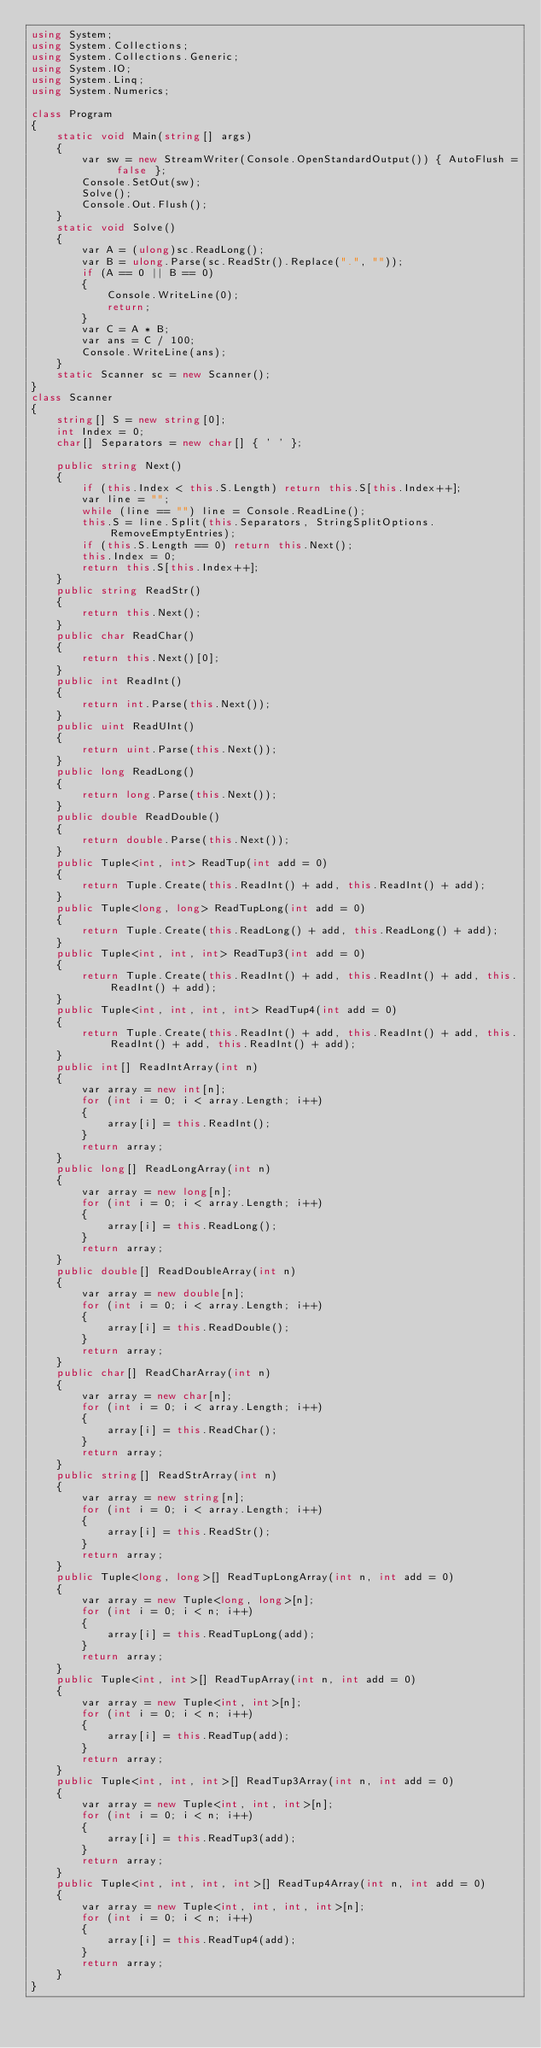<code> <loc_0><loc_0><loc_500><loc_500><_C#_>using System;
using System.Collections;
using System.Collections.Generic;
using System.IO;
using System.Linq;
using System.Numerics;

class Program
{
    static void Main(string[] args)
    {
        var sw = new StreamWriter(Console.OpenStandardOutput()) { AutoFlush = false };
        Console.SetOut(sw);
        Solve();
        Console.Out.Flush();
    }
    static void Solve()
    {
        var A = (ulong)sc.ReadLong();
        var B = ulong.Parse(sc.ReadStr().Replace(".", ""));
        if (A == 0 || B == 0)
        {
            Console.WriteLine(0);
            return;
        }
        var C = A * B;
        var ans = C / 100;
        Console.WriteLine(ans);
    }
    static Scanner sc = new Scanner();
}
class Scanner
{
    string[] S = new string[0];
    int Index = 0;
    char[] Separators = new char[] { ' ' };

    public string Next()
    {
        if (this.Index < this.S.Length) return this.S[this.Index++];
        var line = "";
        while (line == "") line = Console.ReadLine();
        this.S = line.Split(this.Separators, StringSplitOptions.RemoveEmptyEntries);
        if (this.S.Length == 0) return this.Next();
        this.Index = 0;
        return this.S[this.Index++];
    }
    public string ReadStr()
    {
        return this.Next();
    }
    public char ReadChar()
    {
        return this.Next()[0];
    }
    public int ReadInt()
    {
        return int.Parse(this.Next());
    }
    public uint ReadUInt()
    {
        return uint.Parse(this.Next());
    }
    public long ReadLong()
    {
        return long.Parse(this.Next());
    }
    public double ReadDouble()
    {
        return double.Parse(this.Next());
    }
    public Tuple<int, int> ReadTup(int add = 0)
    {
        return Tuple.Create(this.ReadInt() + add, this.ReadInt() + add);
    }
    public Tuple<long, long> ReadTupLong(int add = 0)
    {
        return Tuple.Create(this.ReadLong() + add, this.ReadLong() + add);
    }
    public Tuple<int, int, int> ReadTup3(int add = 0)
    {
        return Tuple.Create(this.ReadInt() + add, this.ReadInt() + add, this.ReadInt() + add);
    }
    public Tuple<int, int, int, int> ReadTup4(int add = 0)
    {
        return Tuple.Create(this.ReadInt() + add, this.ReadInt() + add, this.ReadInt() + add, this.ReadInt() + add);
    }
    public int[] ReadIntArray(int n)
    {
        var array = new int[n];
        for (int i = 0; i < array.Length; i++)
        {
            array[i] = this.ReadInt();
        }
        return array;
    }
    public long[] ReadLongArray(int n)
    {
        var array = new long[n];
        for (int i = 0; i < array.Length; i++)
        {
            array[i] = this.ReadLong();
        }
        return array;
    }
    public double[] ReadDoubleArray(int n)
    {
        var array = new double[n];
        for (int i = 0; i < array.Length; i++)
        {
            array[i] = this.ReadDouble();
        }
        return array;
    }
    public char[] ReadCharArray(int n)
    {
        var array = new char[n];
        for (int i = 0; i < array.Length; i++)
        {
            array[i] = this.ReadChar();
        }
        return array;
    }
    public string[] ReadStrArray(int n)
    {
        var array = new string[n];
        for (int i = 0; i < array.Length; i++)
        {
            array[i] = this.ReadStr();
        }
        return array;
    }
    public Tuple<long, long>[] ReadTupLongArray(int n, int add = 0)
    {
        var array = new Tuple<long, long>[n];
        for (int i = 0; i < n; i++)
        {
            array[i] = this.ReadTupLong(add);
        }
        return array;
    }
    public Tuple<int, int>[] ReadTupArray(int n, int add = 0)
    {
        var array = new Tuple<int, int>[n];
        for (int i = 0; i < n; i++)
        {
            array[i] = this.ReadTup(add);
        }
        return array;
    }
    public Tuple<int, int, int>[] ReadTup3Array(int n, int add = 0)
    {
        var array = new Tuple<int, int, int>[n];
        for (int i = 0; i < n; i++)
        {
            array[i] = this.ReadTup3(add);
        }
        return array;
    }
    public Tuple<int, int, int, int>[] ReadTup4Array(int n, int add = 0)
    {
        var array = new Tuple<int, int, int, int>[n];
        for (int i = 0; i < n; i++)
        {
            array[i] = this.ReadTup4(add);
        }
        return array;
    }
}
</code> 